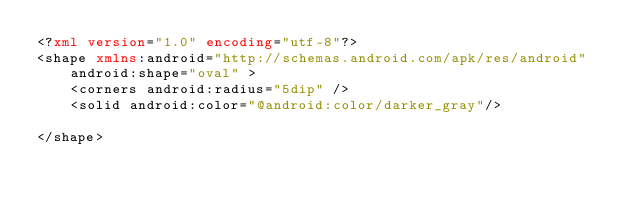Convert code to text. <code><loc_0><loc_0><loc_500><loc_500><_XML_><?xml version="1.0" encoding="utf-8"?>
<shape xmlns:android="http://schemas.android.com/apk/res/android" 
    android:shape="oval" >
    <corners android:radius="5dip" />
    <solid android:color="@android:color/darker_gray"/>

</shape>
</code> 